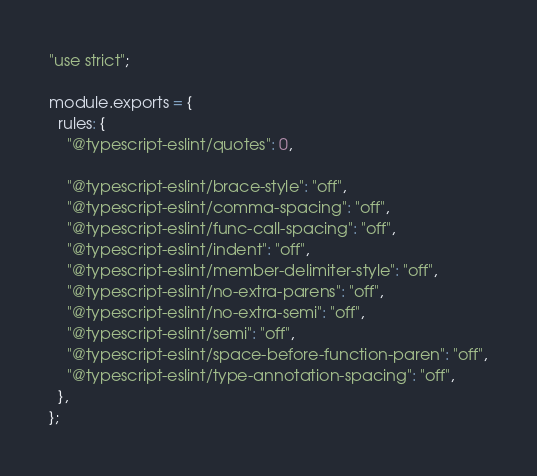Convert code to text. <code><loc_0><loc_0><loc_500><loc_500><_JavaScript_>"use strict";

module.exports = {
  rules: {
    "@typescript-eslint/quotes": 0,

    "@typescript-eslint/brace-style": "off",
    "@typescript-eslint/comma-spacing": "off",
    "@typescript-eslint/func-call-spacing": "off",
    "@typescript-eslint/indent": "off",
    "@typescript-eslint/member-delimiter-style": "off",
    "@typescript-eslint/no-extra-parens": "off",
    "@typescript-eslint/no-extra-semi": "off",
    "@typescript-eslint/semi": "off",
    "@typescript-eslint/space-before-function-paren": "off",
    "@typescript-eslint/type-annotation-spacing": "off",
  },
};
</code> 